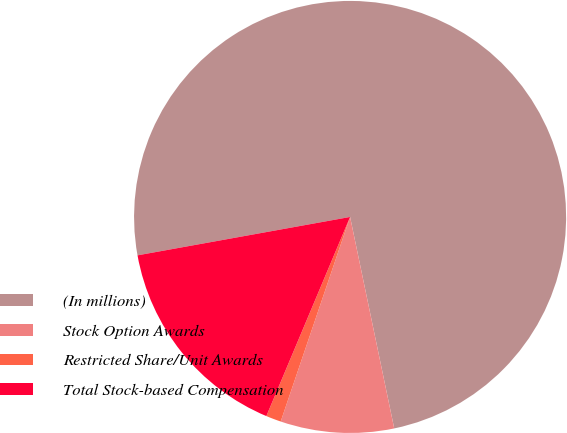<chart> <loc_0><loc_0><loc_500><loc_500><pie_chart><fcel>(In millions)<fcel>Stock Option Awards<fcel>Restricted Share/Unit Awards<fcel>Total Stock-based Compensation<nl><fcel>74.57%<fcel>8.48%<fcel>1.13%<fcel>15.82%<nl></chart> 